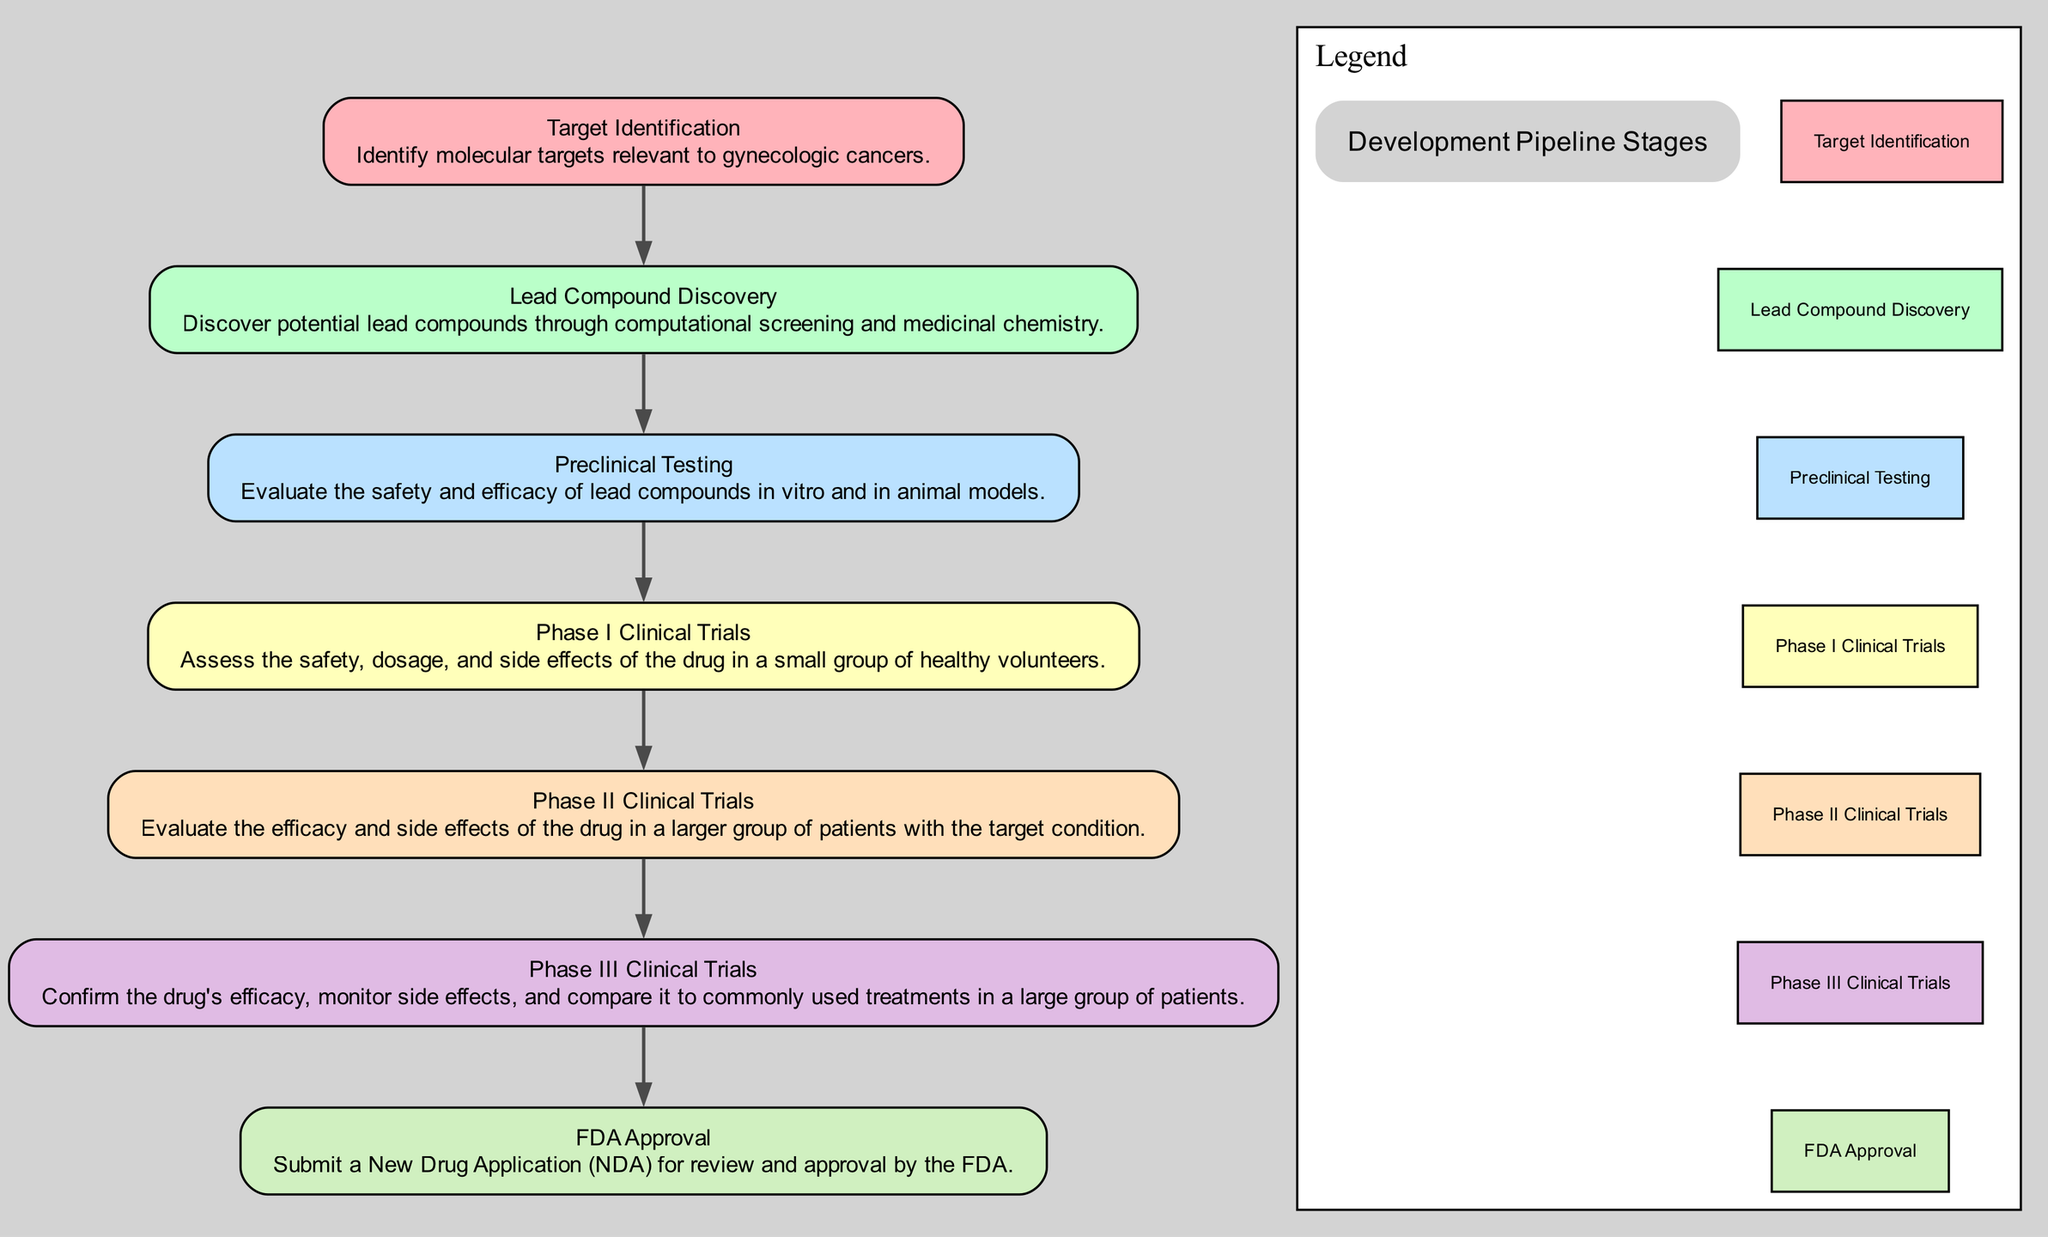What is the first stage in the development pipeline? The first stage listed in the diagram is "Target Identification." It is the initial step that sets the foundation for the subsequent stages.
Answer: Target Identification How many stages are there in the development pipeline? Counting the stages presented in the diagram, there are seven stages from "Target Identification" to "FDA Approval."
Answer: Seven What is the primary focus of the "Preclinical Testing" stage? The description under "Preclinical Testing" mentions evaluating the safety and efficacy of lead compounds in laboratory and animal models, which is essential before advancing to human trials.
Answer: Safety and efficacy During which phase are the drug's side effects assessed? "Phase I Clinical Trials" involves assessing the safety, dosage, and side effects of the drug in a small group of healthy volunteers, making this the stage where side effects are first evaluated.
Answer: Phase I Clinical Trials What is the final step in the development pipeline? The last step mentioned in the development pipeline is "FDA Approval," which involves submitting a New Drug Application for review and approval.
Answer: FDA Approval Which stage follows "Lead Compound Discovery"? According to the diagram, the stage that follows "Lead Compound Discovery" is "Preclinical Testing," indicating the progression from compound discovery to safety and efficacy evaluation.
Answer: Preclinical Testing What is assessed during "Phase III Clinical Trials"? The description for "Phase III Clinical Trials" states that it is meant to confirm the drug's efficacy, monitor side effects, and compare it to existing treatments, focusing on comprehensive evaluation in a larger patient group.
Answer: Confirm efficacy Which stage deals with the assignment of personalized treatment plans? In the "Patient Stratification Based on Biomarker Analysis" flow, the step for either assigning personalized treatment plans is "Therapy Assignment," where patients receive treatment tailored to their biomarker profiles.
Answer: Therapy Assignment How is hit selection performed in high-throughput screening? The "Hit Selection" phase indicates identifying promising 'hit' compounds that show desired activity based on previous screening data, which is a critical step in drug discovery.
Answer: Desired activity 